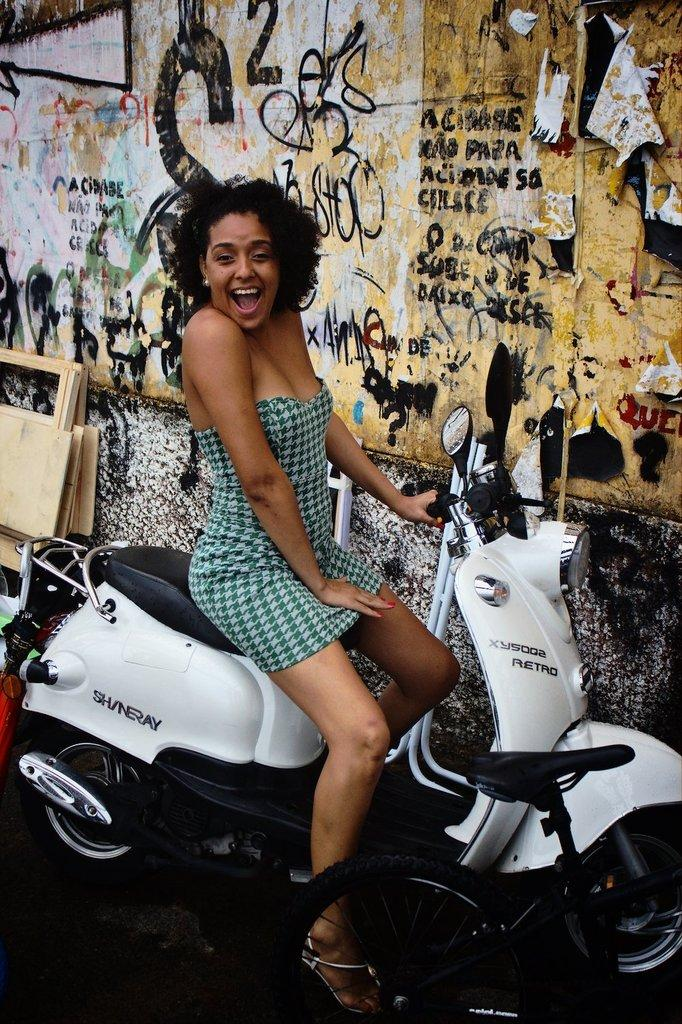Who is the main subject in the image? There is a woman in the image. What is the woman doing in the image? The woman is sitting on a bike. What is the woman's facial expression in the image? The woman is smiling. What can be seen in the background of the image? There is a wall in the background of the image. What type of government is depicted in the image? There is no government depicted in the image; it features a woman sitting on a bike and smiling. How many elbows can be seen in the image? There is no mention of elbows in the image; it only shows a woman sitting on a bike and smiling, with a wall in the background. 